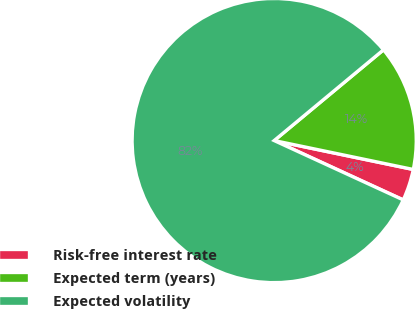Convert chart to OTSL. <chart><loc_0><loc_0><loc_500><loc_500><pie_chart><fcel>Risk-free interest rate<fcel>Expected term (years)<fcel>Expected volatility<nl><fcel>3.6%<fcel>14.29%<fcel>82.11%<nl></chart> 